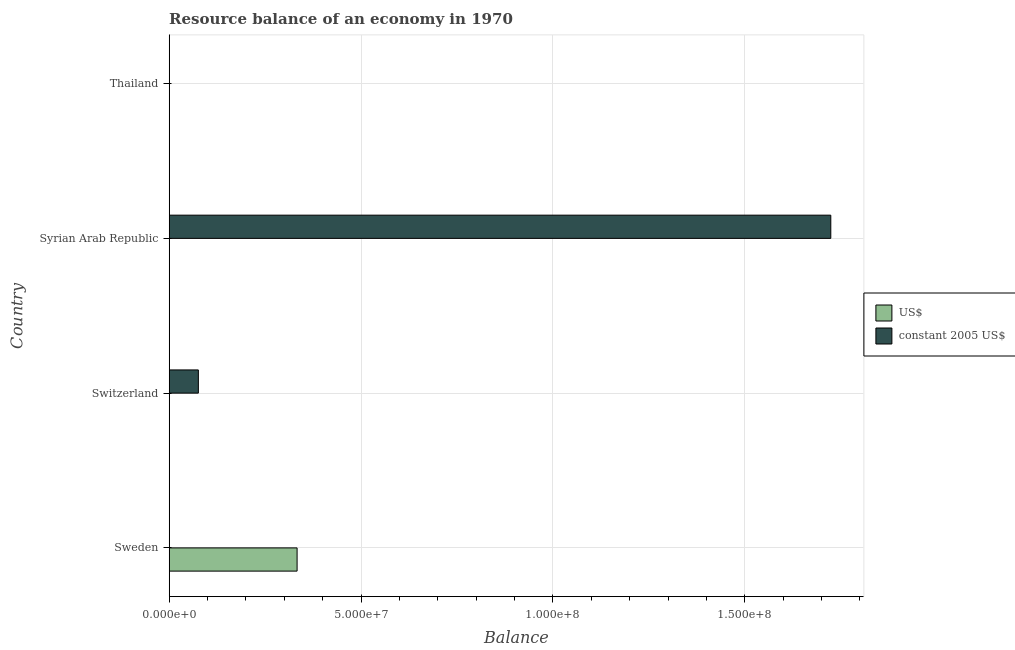Are the number of bars on each tick of the Y-axis equal?
Ensure brevity in your answer.  No. How many bars are there on the 4th tick from the bottom?
Your answer should be very brief. 0. What is the resource balance in us$ in Sweden?
Provide a succinct answer. 3.33e+07. Across all countries, what is the maximum resource balance in us$?
Keep it short and to the point. 3.33e+07. Across all countries, what is the minimum resource balance in constant us$?
Your answer should be very brief. 0. In which country was the resource balance in constant us$ maximum?
Your answer should be compact. Syrian Arab Republic. What is the total resource balance in constant us$ in the graph?
Provide a short and direct response. 1.80e+08. What is the difference between the resource balance in constant us$ in Sweden and that in Syrian Arab Republic?
Your answer should be compact. -1.72e+08. What is the difference between the resource balance in us$ in Sweden and the resource balance in constant us$ in Thailand?
Your answer should be compact. 3.33e+07. What is the average resource balance in constant us$ per country?
Your answer should be compact. 4.50e+07. In how many countries, is the resource balance in us$ greater than 120000000 units?
Your answer should be compact. 0. What is the difference between the highest and the second highest resource balance in constant us$?
Offer a very short reply. 1.65e+08. What is the difference between the highest and the lowest resource balance in us$?
Your answer should be very brief. 3.33e+07. In how many countries, is the resource balance in us$ greater than the average resource balance in us$ taken over all countries?
Keep it short and to the point. 1. Where does the legend appear in the graph?
Keep it short and to the point. Center right. How many legend labels are there?
Ensure brevity in your answer.  2. What is the title of the graph?
Give a very brief answer. Resource balance of an economy in 1970. Does "Travel Items" appear as one of the legend labels in the graph?
Provide a short and direct response. No. What is the label or title of the X-axis?
Offer a terse response. Balance. What is the label or title of the Y-axis?
Offer a very short reply. Country. What is the Balance of US$ in Sweden?
Make the answer very short. 3.33e+07. What is the Balance of constant 2005 US$ in Sweden?
Provide a short and direct response. 2.91e+04. What is the Balance in US$ in Switzerland?
Offer a terse response. 0. What is the Balance in constant 2005 US$ in Switzerland?
Provide a short and direct response. 7.60e+06. What is the Balance of US$ in Syrian Arab Republic?
Give a very brief answer. 0. What is the Balance in constant 2005 US$ in Syrian Arab Republic?
Offer a terse response. 1.72e+08. Across all countries, what is the maximum Balance of US$?
Ensure brevity in your answer.  3.33e+07. Across all countries, what is the maximum Balance in constant 2005 US$?
Offer a very short reply. 1.72e+08. What is the total Balance in US$ in the graph?
Your answer should be very brief. 3.33e+07. What is the total Balance of constant 2005 US$ in the graph?
Your response must be concise. 1.80e+08. What is the difference between the Balance of constant 2005 US$ in Sweden and that in Switzerland?
Your response must be concise. -7.57e+06. What is the difference between the Balance of constant 2005 US$ in Sweden and that in Syrian Arab Republic?
Ensure brevity in your answer.  -1.72e+08. What is the difference between the Balance in constant 2005 US$ in Switzerland and that in Syrian Arab Republic?
Offer a terse response. -1.65e+08. What is the difference between the Balance of US$ in Sweden and the Balance of constant 2005 US$ in Switzerland?
Provide a short and direct response. 2.57e+07. What is the difference between the Balance of US$ in Sweden and the Balance of constant 2005 US$ in Syrian Arab Republic?
Ensure brevity in your answer.  -1.39e+08. What is the average Balance in US$ per country?
Ensure brevity in your answer.  8.33e+06. What is the average Balance in constant 2005 US$ per country?
Give a very brief answer. 4.50e+07. What is the difference between the Balance in US$ and Balance in constant 2005 US$ in Sweden?
Your answer should be very brief. 3.33e+07. What is the ratio of the Balance of constant 2005 US$ in Sweden to that in Switzerland?
Your response must be concise. 0. What is the ratio of the Balance of constant 2005 US$ in Switzerland to that in Syrian Arab Republic?
Give a very brief answer. 0.04. What is the difference between the highest and the second highest Balance in constant 2005 US$?
Offer a very short reply. 1.65e+08. What is the difference between the highest and the lowest Balance in US$?
Offer a terse response. 3.33e+07. What is the difference between the highest and the lowest Balance of constant 2005 US$?
Make the answer very short. 1.72e+08. 